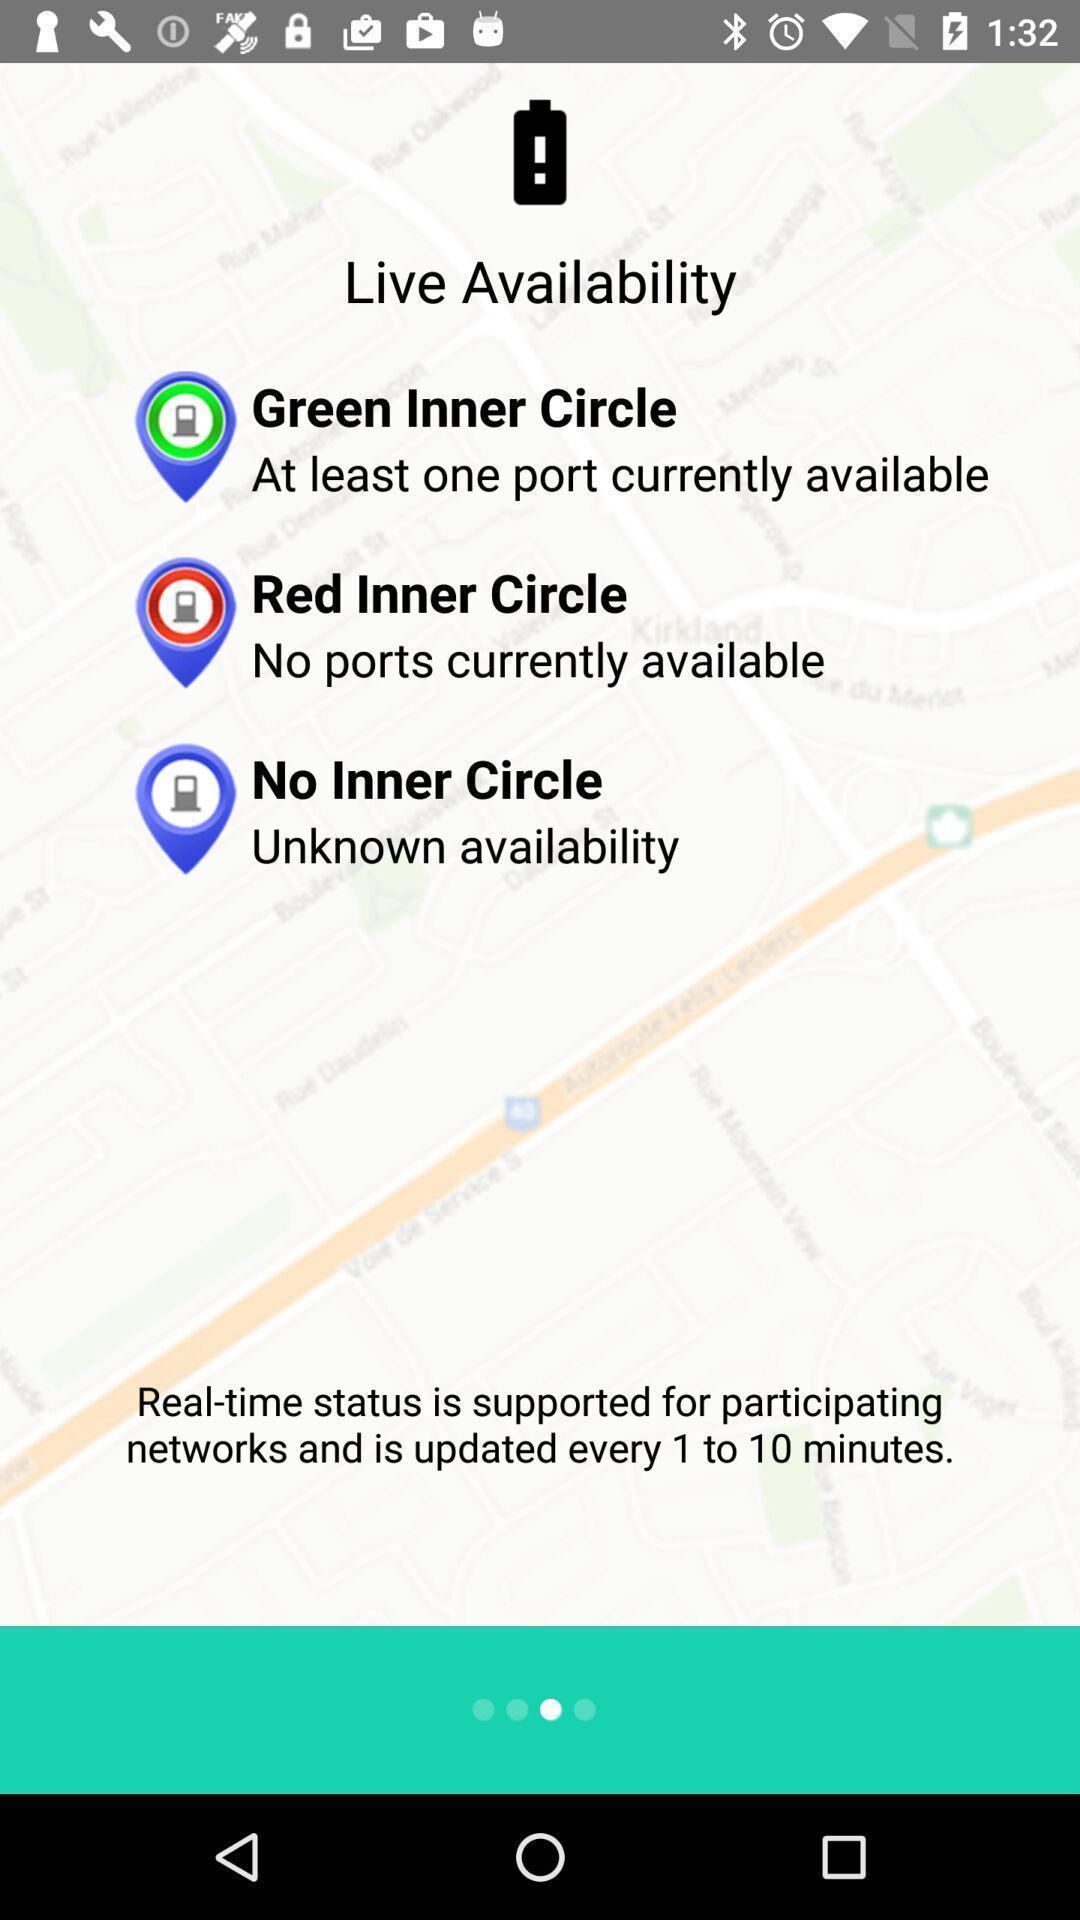Describe the content in this image. Welcome page of a stations map app. 